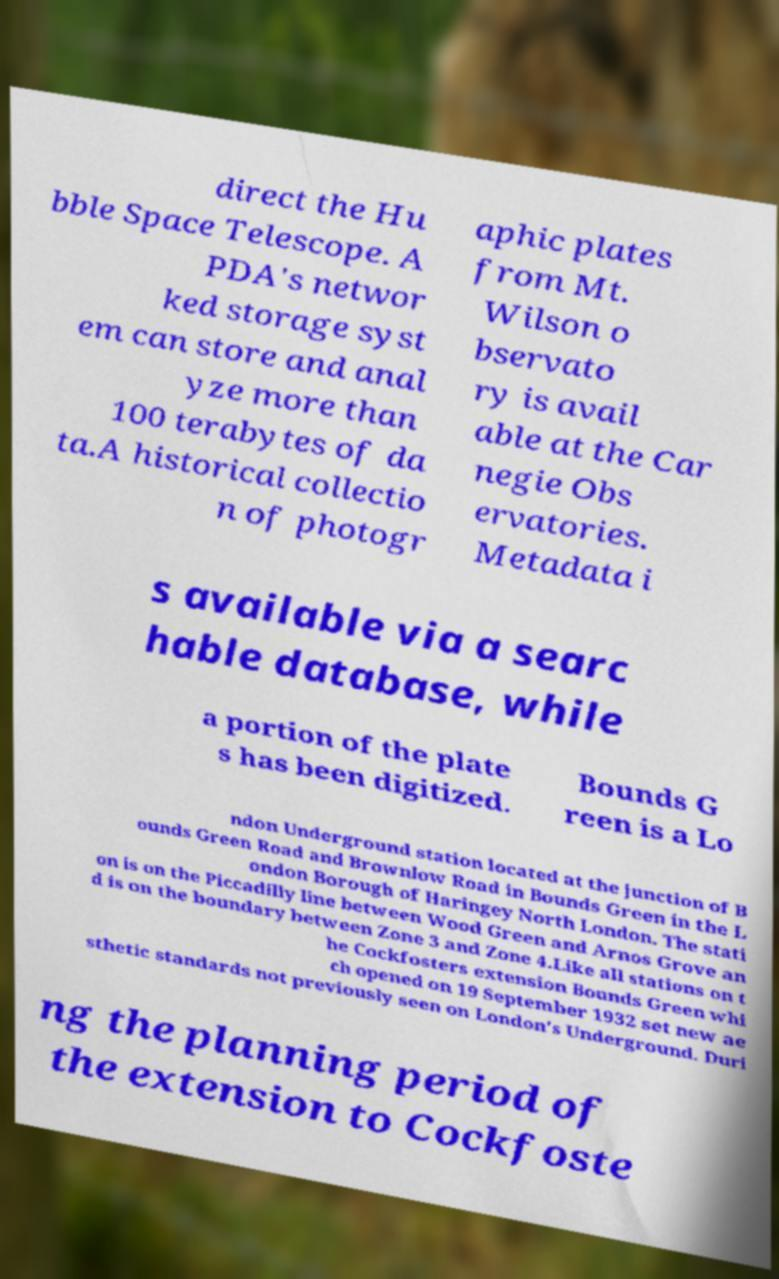Please identify and transcribe the text found in this image. direct the Hu bble Space Telescope. A PDA's networ ked storage syst em can store and anal yze more than 100 terabytes of da ta.A historical collectio n of photogr aphic plates from Mt. Wilson o bservato ry is avail able at the Car negie Obs ervatories. Metadata i s available via a searc hable database, while a portion of the plate s has been digitized. Bounds G reen is a Lo ndon Underground station located at the junction of B ounds Green Road and Brownlow Road in Bounds Green in the L ondon Borough of Haringey North London. The stati on is on the Piccadilly line between Wood Green and Arnos Grove an d is on the boundary between Zone 3 and Zone 4.Like all stations on t he Cockfosters extension Bounds Green whi ch opened on 19 September 1932 set new ae sthetic standards not previously seen on London's Underground. Duri ng the planning period of the extension to Cockfoste 